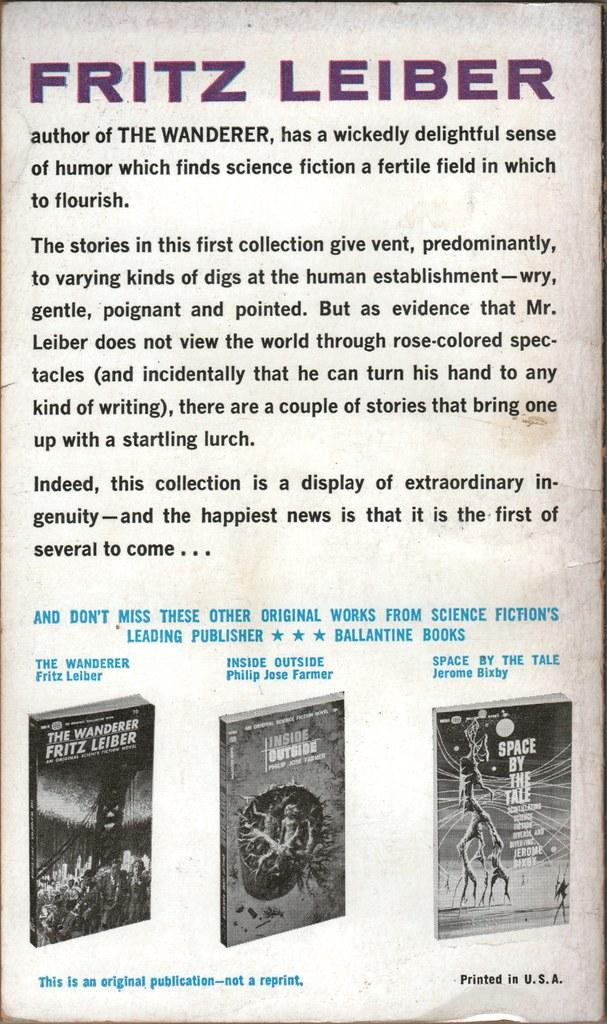Provide a one-sentence caption for the provided image. Page that says Fritz Leiber in purple on top and a photo of three books on the bottom. 